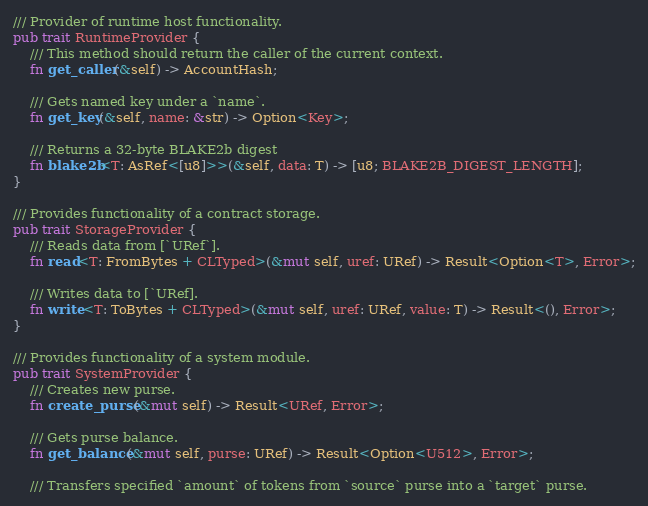Convert code to text. <code><loc_0><loc_0><loc_500><loc_500><_Rust_>/// Provider of runtime host functionality.
pub trait RuntimeProvider {
    /// This method should return the caller of the current context.
    fn get_caller(&self) -> AccountHash;

    /// Gets named key under a `name`.
    fn get_key(&self, name: &str) -> Option<Key>;

    /// Returns a 32-byte BLAKE2b digest
    fn blake2b<T: AsRef<[u8]>>(&self, data: T) -> [u8; BLAKE2B_DIGEST_LENGTH];
}

/// Provides functionality of a contract storage.
pub trait StorageProvider {
    /// Reads data from [`URef`].
    fn read<T: FromBytes + CLTyped>(&mut self, uref: URef) -> Result<Option<T>, Error>;

    /// Writes data to [`URef].
    fn write<T: ToBytes + CLTyped>(&mut self, uref: URef, value: T) -> Result<(), Error>;
}

/// Provides functionality of a system module.
pub trait SystemProvider {
    /// Creates new purse.
    fn create_purse(&mut self) -> Result<URef, Error>;

    /// Gets purse balance.
    fn get_balance(&mut self, purse: URef) -> Result<Option<U512>, Error>;

    /// Transfers specified `amount` of tokens from `source` purse into a `target` purse.</code> 